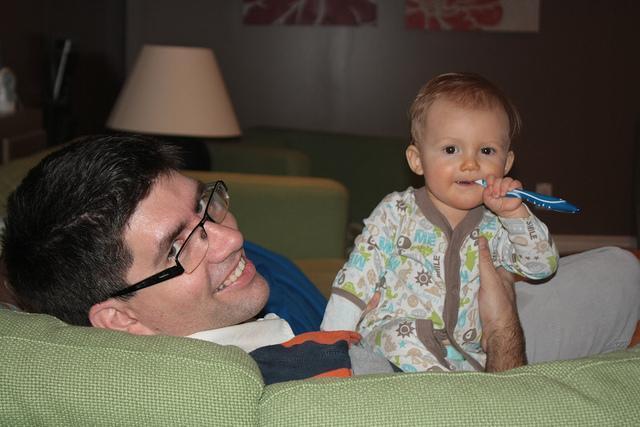How many people can be seen?
Give a very brief answer. 2. How many couches are in the photo?
Give a very brief answer. 1. How many teddy bears are in the nest?
Give a very brief answer. 0. 